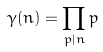<formula> <loc_0><loc_0><loc_500><loc_500>\gamma ( n ) = \prod _ { p | n } p</formula> 